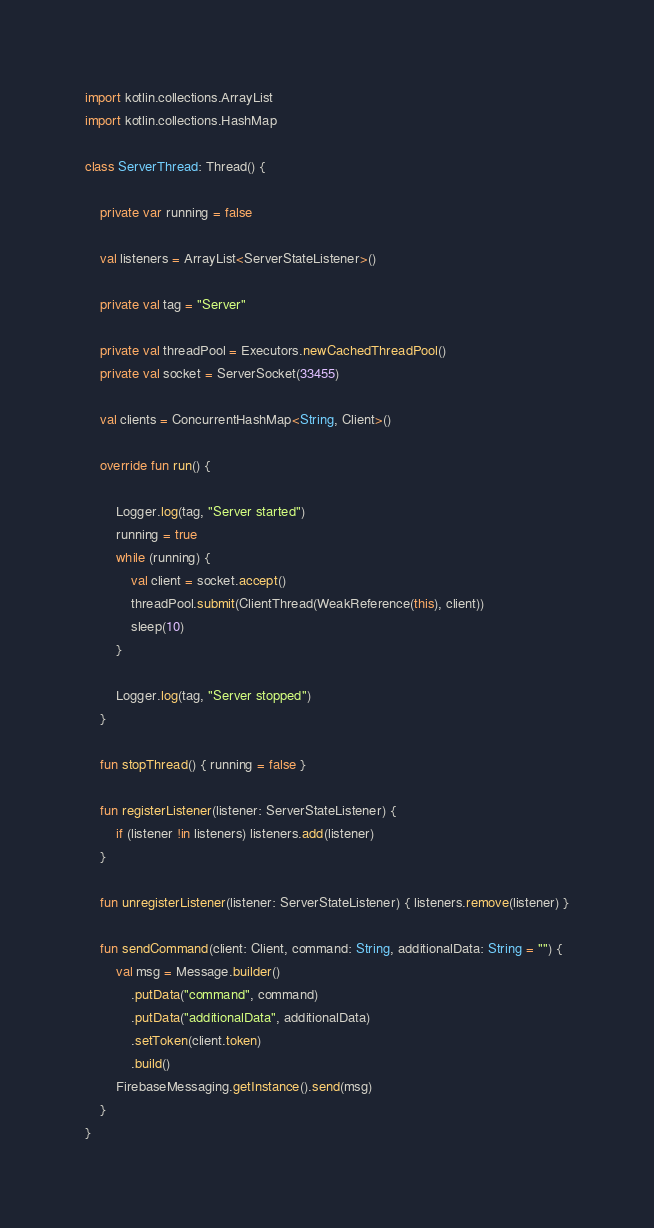<code> <loc_0><loc_0><loc_500><loc_500><_Kotlin_>import kotlin.collections.ArrayList
import kotlin.collections.HashMap

class ServerThread: Thread() {

    private var running = false

    val listeners = ArrayList<ServerStateListener>()

    private val tag = "Server"

    private val threadPool = Executors.newCachedThreadPool()
    private val socket = ServerSocket(33455)

    val clients = ConcurrentHashMap<String, Client>()

    override fun run() {

        Logger.log(tag, "Server started")
        running = true
        while (running) {
            val client = socket.accept()
            threadPool.submit(ClientThread(WeakReference(this), client))
            sleep(10)
        }

        Logger.log(tag, "Server stopped")
    }

    fun stopThread() { running = false }

    fun registerListener(listener: ServerStateListener) {
        if (listener !in listeners) listeners.add(listener)
    }

    fun unregisterListener(listener: ServerStateListener) { listeners.remove(listener) }

    fun sendCommand(client: Client, command: String, additionalData: String = "") {
        val msg = Message.builder()
            .putData("command", command)
            .putData("additionalData", additionalData)
            .setToken(client.token)
            .build()
        FirebaseMessaging.getInstance().send(msg)
    }
}</code> 